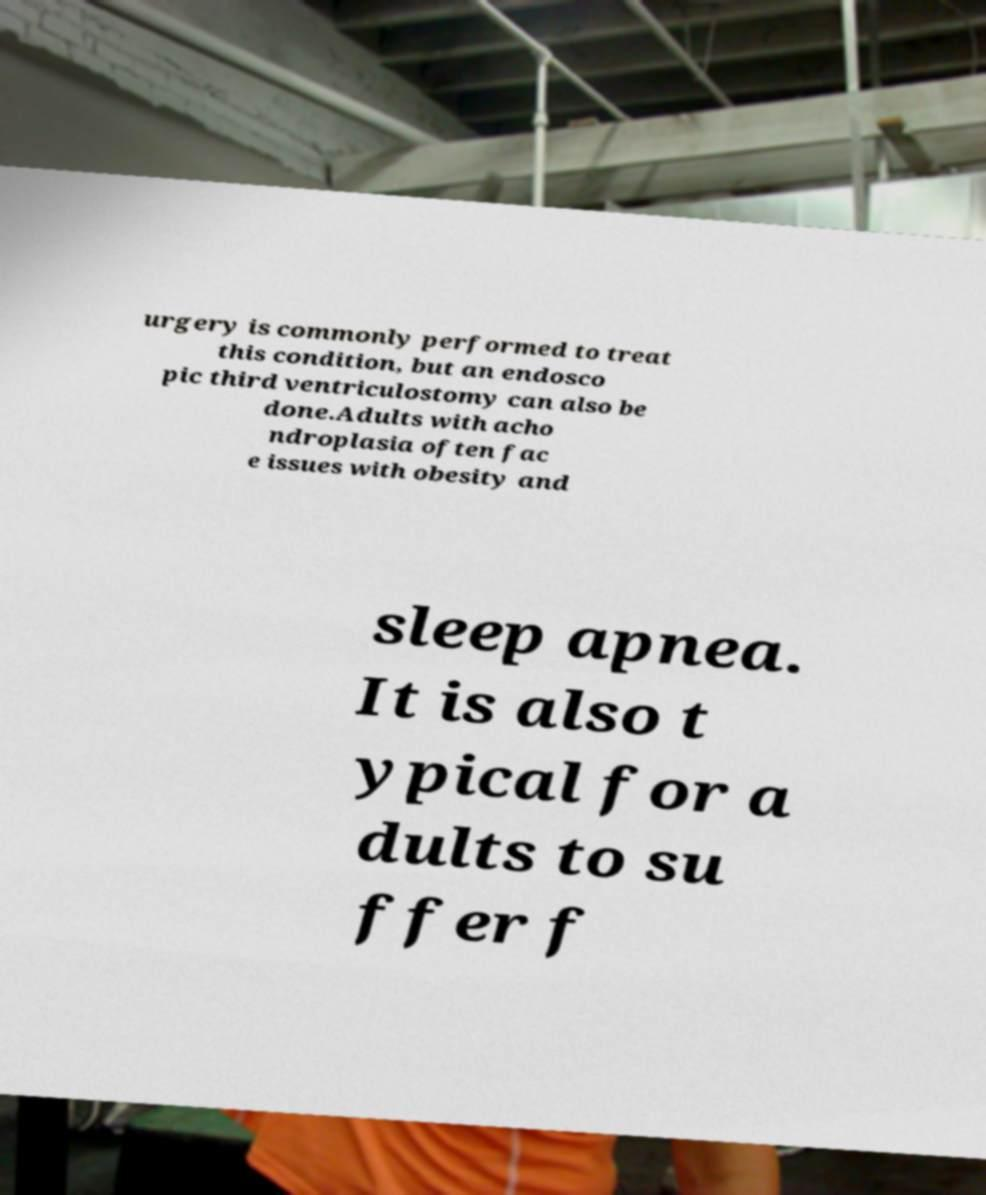Please read and relay the text visible in this image. What does it say? urgery is commonly performed to treat this condition, but an endosco pic third ventriculostomy can also be done.Adults with acho ndroplasia often fac e issues with obesity and sleep apnea. It is also t ypical for a dults to su ffer f 